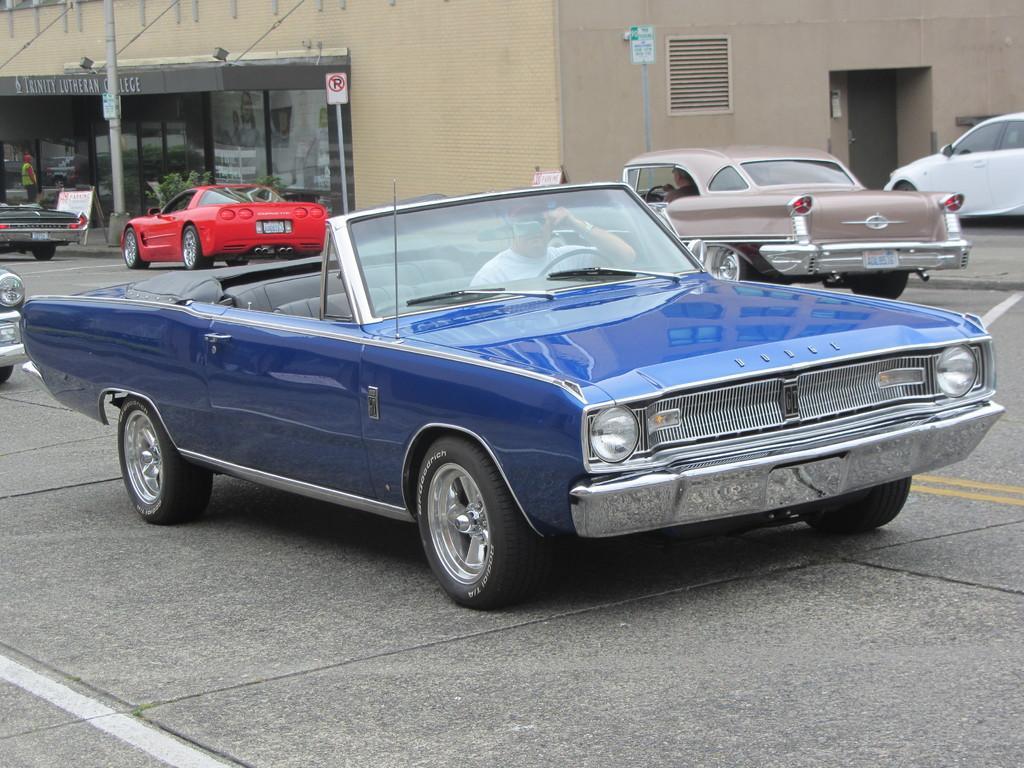Can you describe this image briefly? In this image we can see many vehicles. In the back there is a building. Also there are sign boards with poles. And we can see a person. 